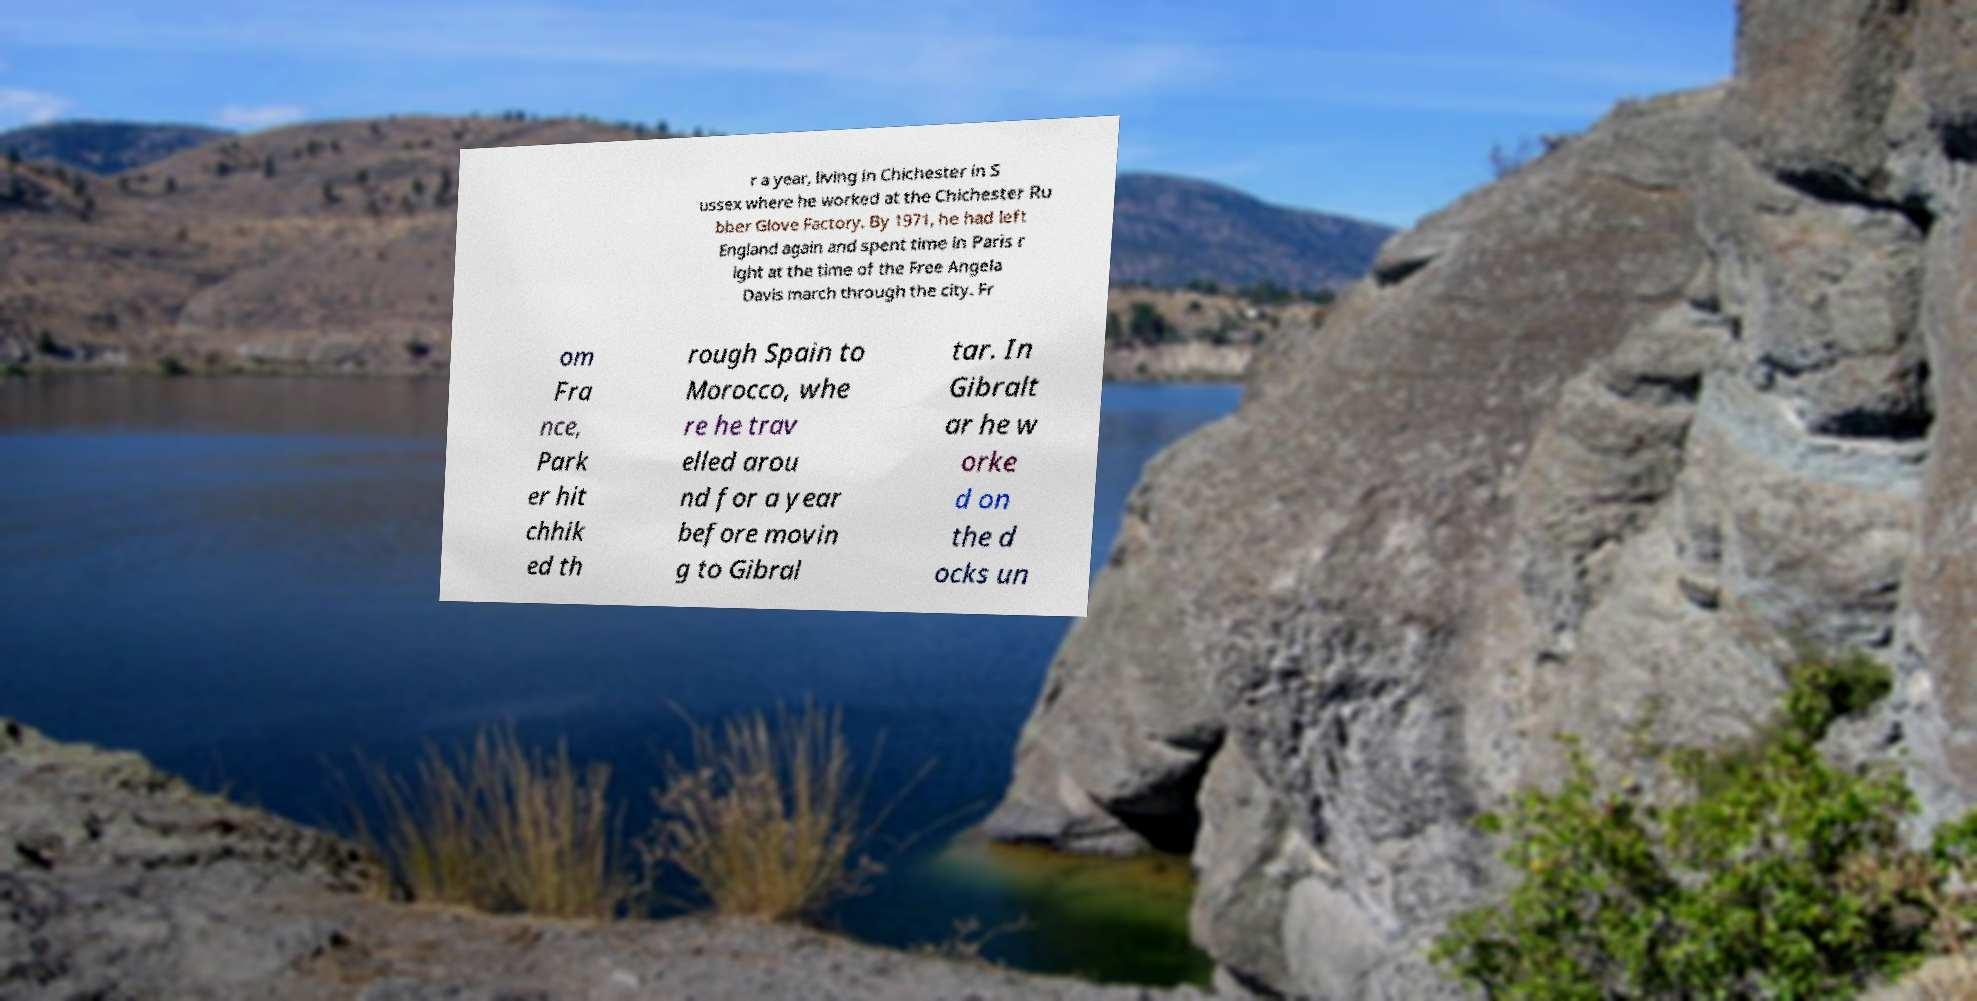I need the written content from this picture converted into text. Can you do that? r a year, living in Chichester in S ussex where he worked at the Chichester Ru bber Glove Factory. By 1971, he had left England again and spent time in Paris r ight at the time of the Free Angela Davis march through the city. Fr om Fra nce, Park er hit chhik ed th rough Spain to Morocco, whe re he trav elled arou nd for a year before movin g to Gibral tar. In Gibralt ar he w orke d on the d ocks un 